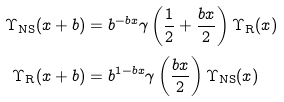<formula> <loc_0><loc_0><loc_500><loc_500>\Upsilon _ { \text {NS} } ( x + b ) & = b ^ { - b x } \gamma \left ( \frac { 1 } { 2 } + \frac { b x } 2 \right ) \Upsilon _ { \text {R} } ( x ) \\ \Upsilon _ { \text {R} } ( x + b ) & = b ^ { 1 - b x } \gamma \left ( \frac { b x } 2 \right ) \Upsilon _ { \text {NS} } ( x )</formula> 